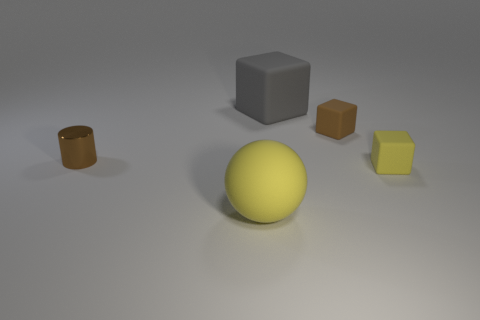Which objects in the image have a geometric shape, and what are those shapes? There are three objects with a geometric shape: one is a cylinder, one is a cube, and one is a small rectangular block.  Can you tell me about the lighting in the scene? Does it affect how the colors of the objects appear? The lighting in the scene is soft and diffused, coming from above. It casts subtle shadows and affects the perception of colors, making them appear less vibrant than they might under direct light. 